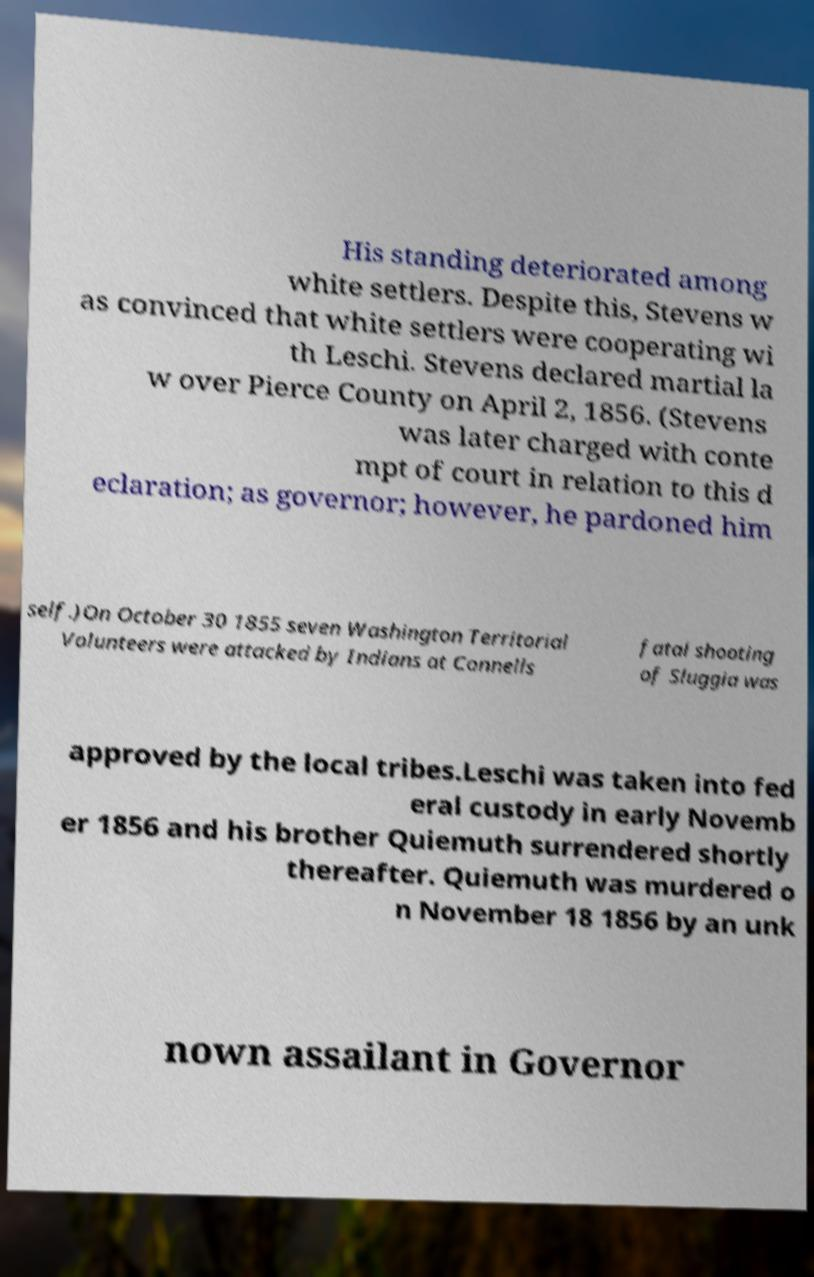Can you read and provide the text displayed in the image?This photo seems to have some interesting text. Can you extract and type it out for me? His standing deteriorated among white settlers. Despite this, Stevens w as convinced that white settlers were cooperating wi th Leschi. Stevens declared martial la w over Pierce County on April 2, 1856. (Stevens was later charged with conte mpt of court in relation to this d eclaration; as governor; however, he pardoned him self.)On October 30 1855 seven Washington Territorial Volunteers were attacked by Indians at Connells fatal shooting of Sluggia was approved by the local tribes.Leschi was taken into fed eral custody in early Novemb er 1856 and his brother Quiemuth surrendered shortly thereafter. Quiemuth was murdered o n November 18 1856 by an unk nown assailant in Governor 